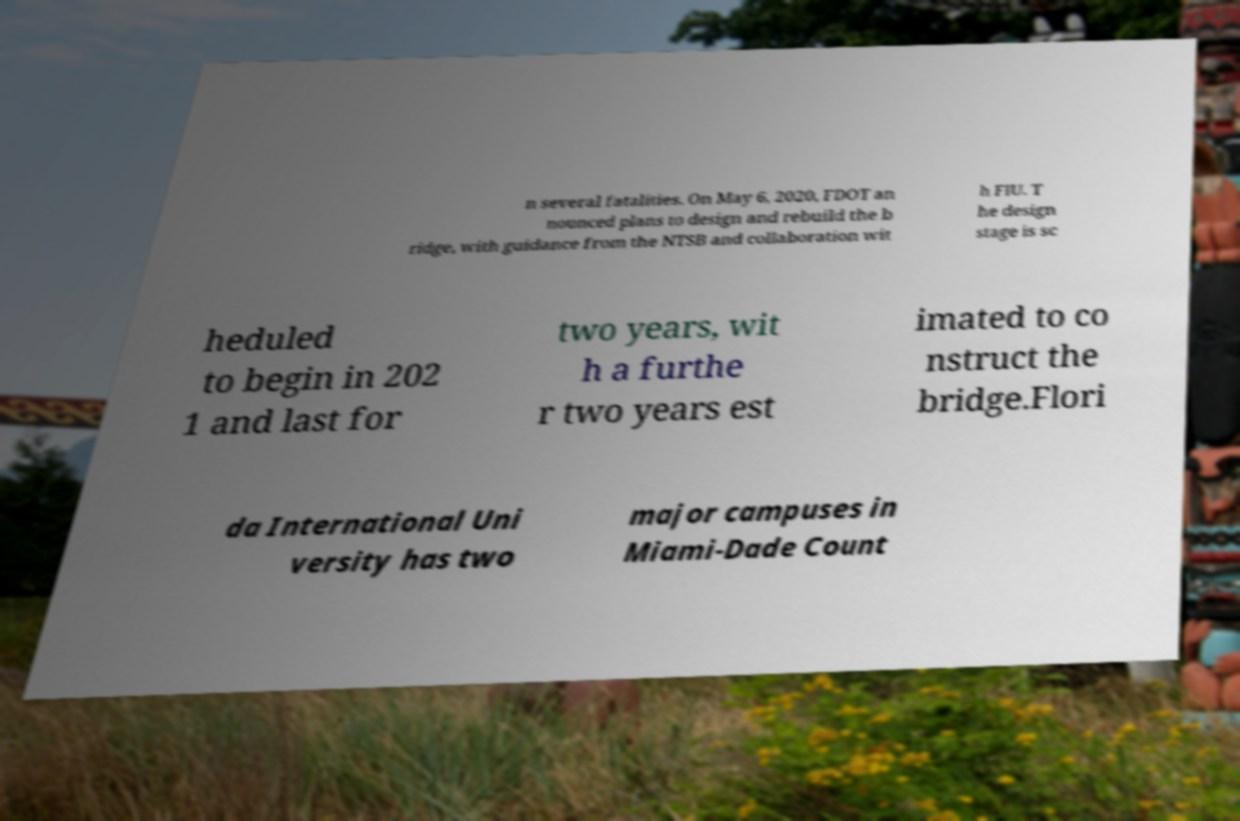For documentation purposes, I need the text within this image transcribed. Could you provide that? n several fatalities. On May 6, 2020, FDOT an nounced plans to design and rebuild the b ridge, with guidance from the NTSB and collaboration wit h FIU. T he design stage is sc heduled to begin in 202 1 and last for two years, wit h a furthe r two years est imated to co nstruct the bridge.Flori da International Uni versity has two major campuses in Miami-Dade Count 